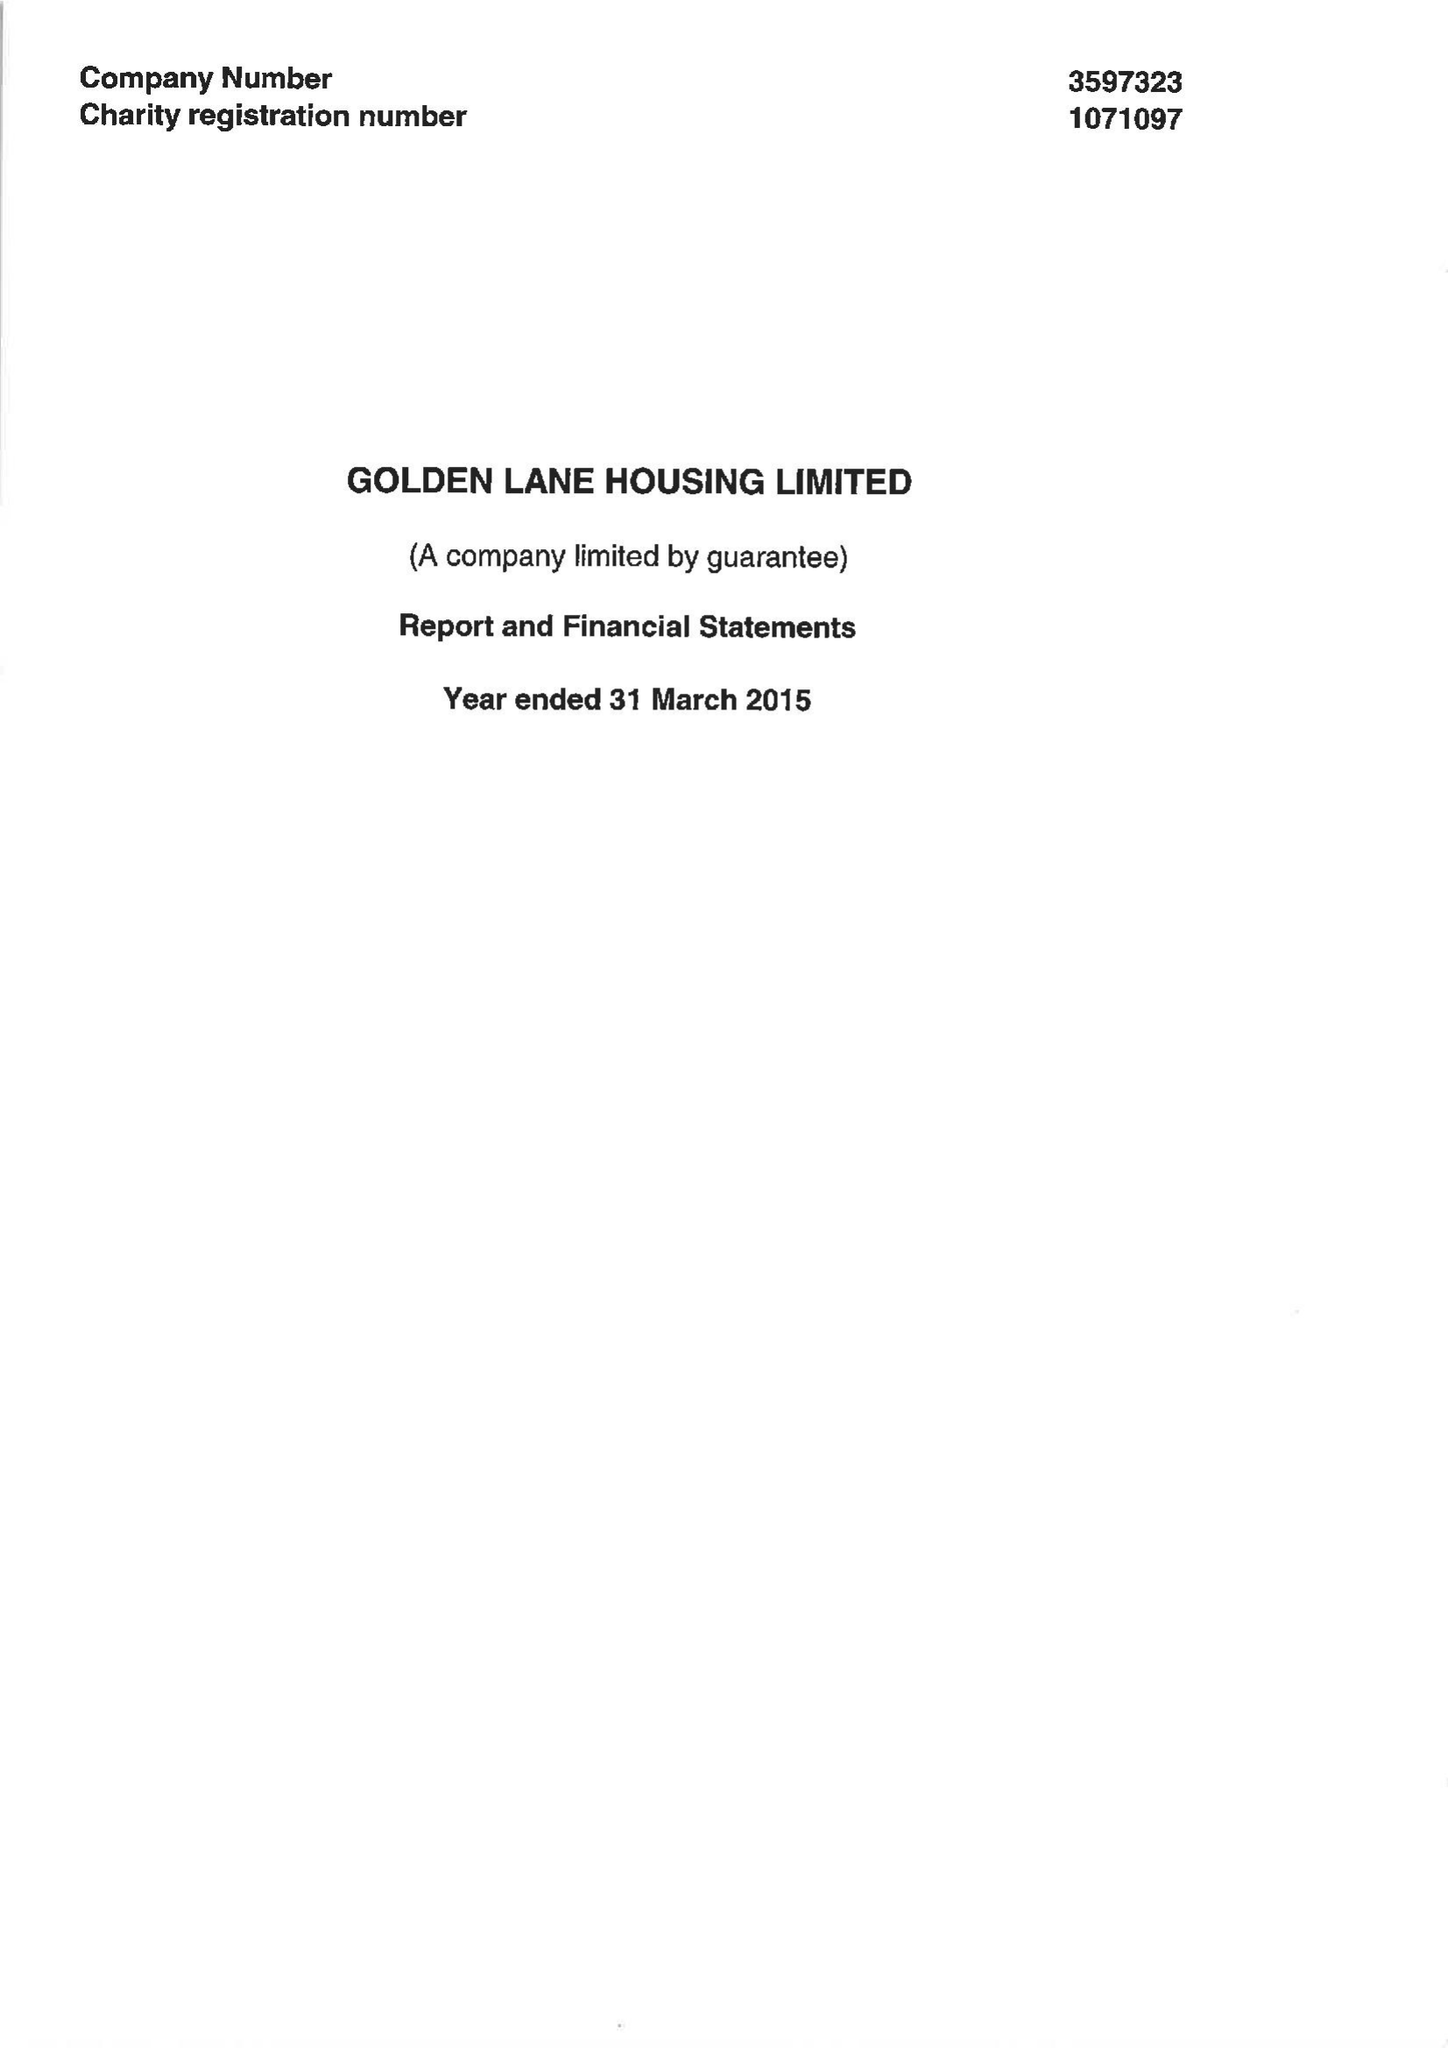What is the value for the charity_number?
Answer the question using a single word or phrase. 1071097 